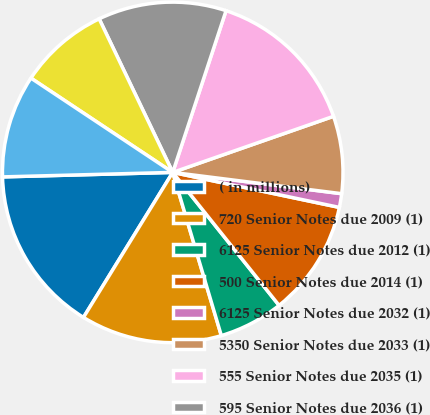Convert chart. <chart><loc_0><loc_0><loc_500><loc_500><pie_chart><fcel>( in millions)<fcel>720 Senior Notes due 2009 (1)<fcel>6125 Senior Notes due 2012 (1)<fcel>500 Senior Notes due 2014 (1)<fcel>6125 Senior Notes due 2032 (1)<fcel>5350 Senior Notes due 2033 (1)<fcel>555 Senior Notes due 2035 (1)<fcel>595 Senior Notes due 2036 (1)<fcel>6125 Junior Subordinated<fcel>650 Junior Subordinated<nl><fcel>15.8%<fcel>13.39%<fcel>6.13%<fcel>10.97%<fcel>1.3%<fcel>7.34%<fcel>14.59%<fcel>12.18%<fcel>8.55%<fcel>9.76%<nl></chart> 